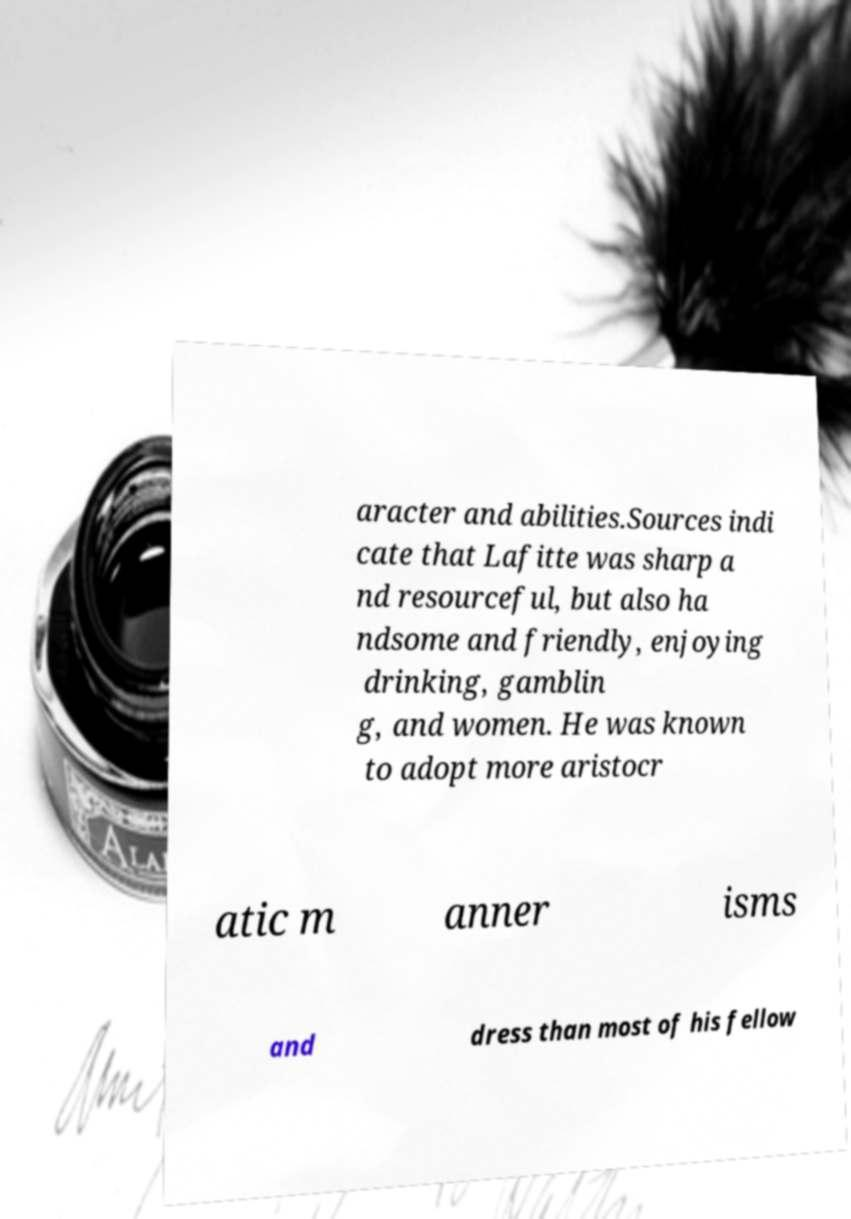Can you accurately transcribe the text from the provided image for me? aracter and abilities.Sources indi cate that Lafitte was sharp a nd resourceful, but also ha ndsome and friendly, enjoying drinking, gamblin g, and women. He was known to adopt more aristocr atic m anner isms and dress than most of his fellow 